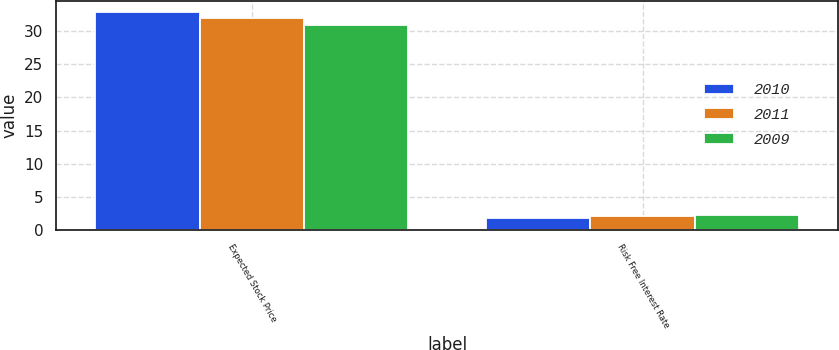<chart> <loc_0><loc_0><loc_500><loc_500><stacked_bar_chart><ecel><fcel>Expected Stock Price<fcel>Risk Free Interest Rate<nl><fcel>2010<fcel>33<fcel>1.7<nl><fcel>2011<fcel>32<fcel>2<nl><fcel>2009<fcel>31<fcel>2.2<nl></chart> 